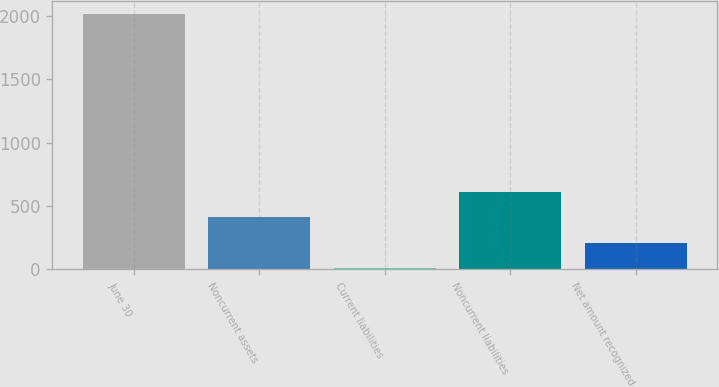Convert chart to OTSL. <chart><loc_0><loc_0><loc_500><loc_500><bar_chart><fcel>June 30<fcel>Noncurrent assets<fcel>Current liabilities<fcel>Noncurrent liabilities<fcel>Net amount recognized<nl><fcel>2019<fcel>408.52<fcel>5.9<fcel>609.83<fcel>207.21<nl></chart> 